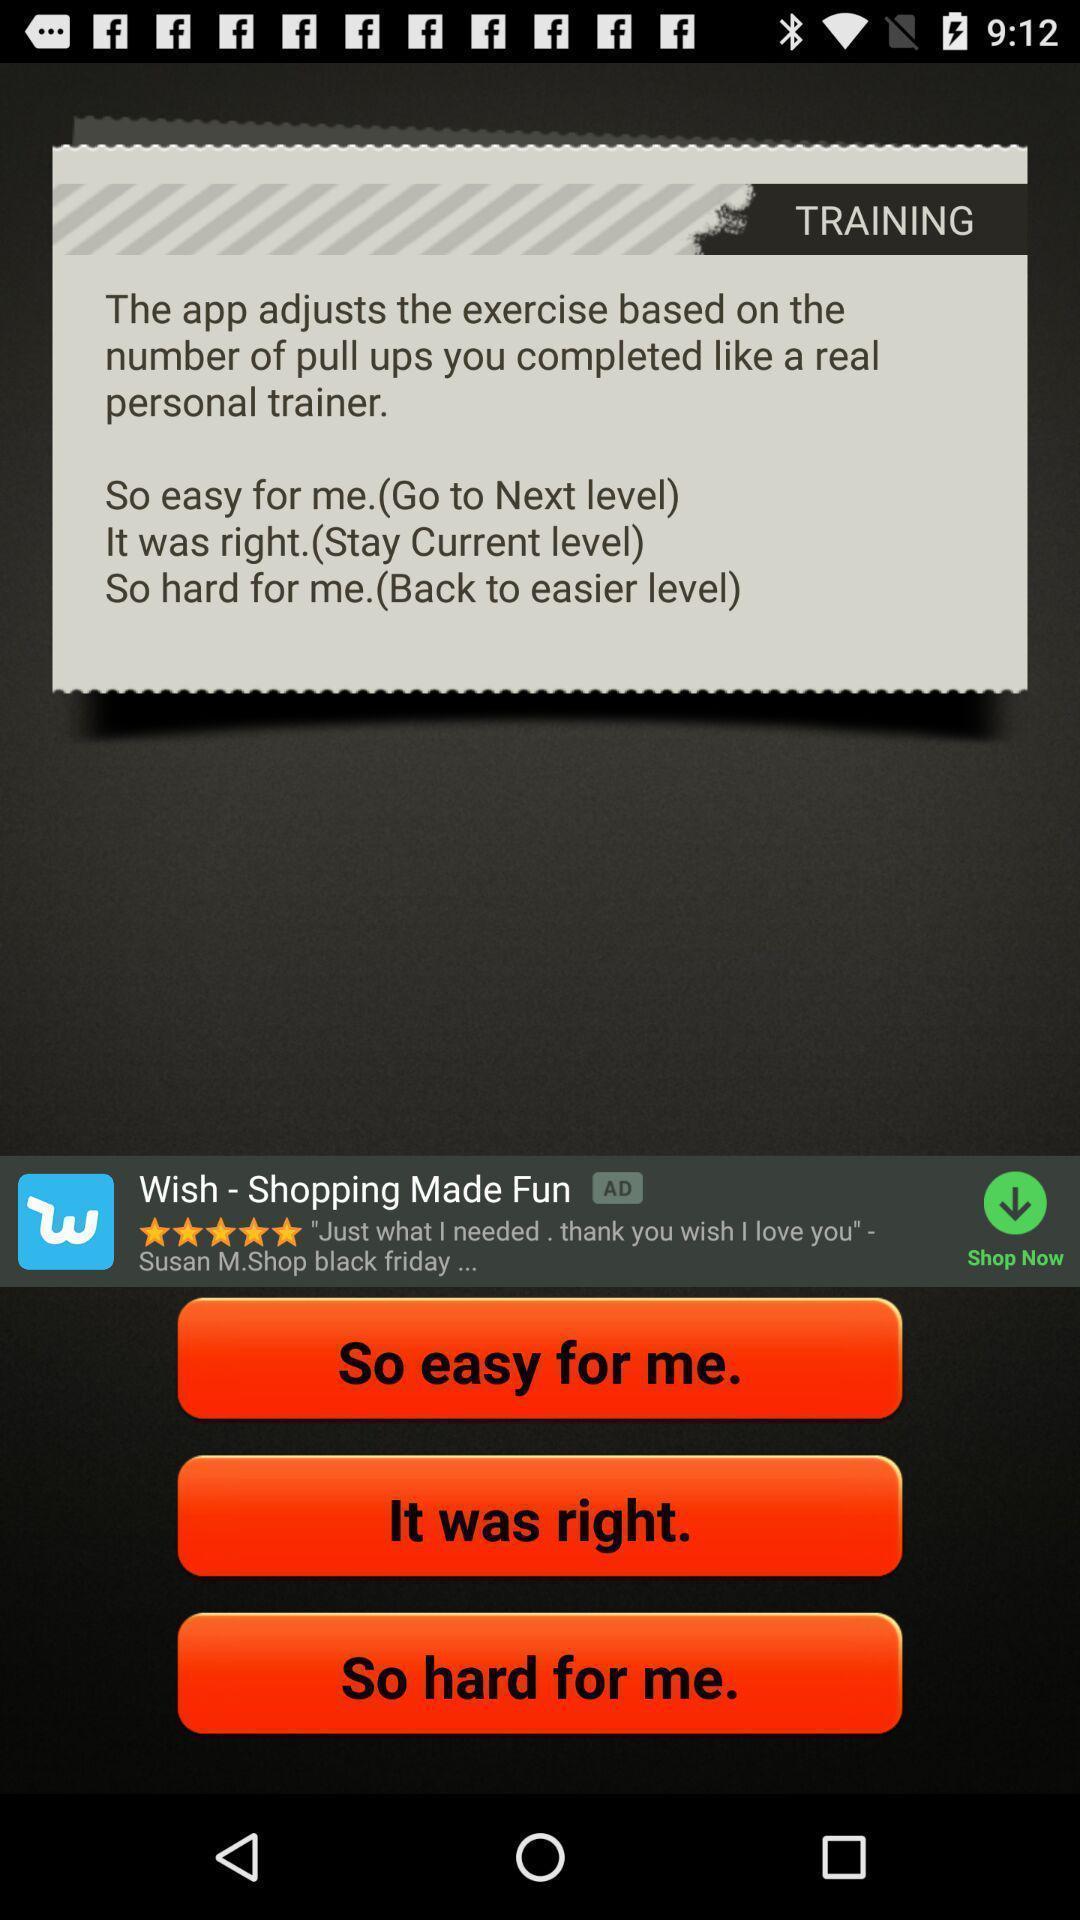Provide a description of this screenshot. Page displaying training information of an exercise app. 